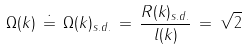Convert formula to latex. <formula><loc_0><loc_0><loc_500><loc_500>\Omega ( k ) \, \doteq \, \Omega ( k ) _ { s . d . } \, = \, \frac { R ( k ) _ { s . d . } } { l ( k ) } \, = \, \sqrt { 2 }</formula> 